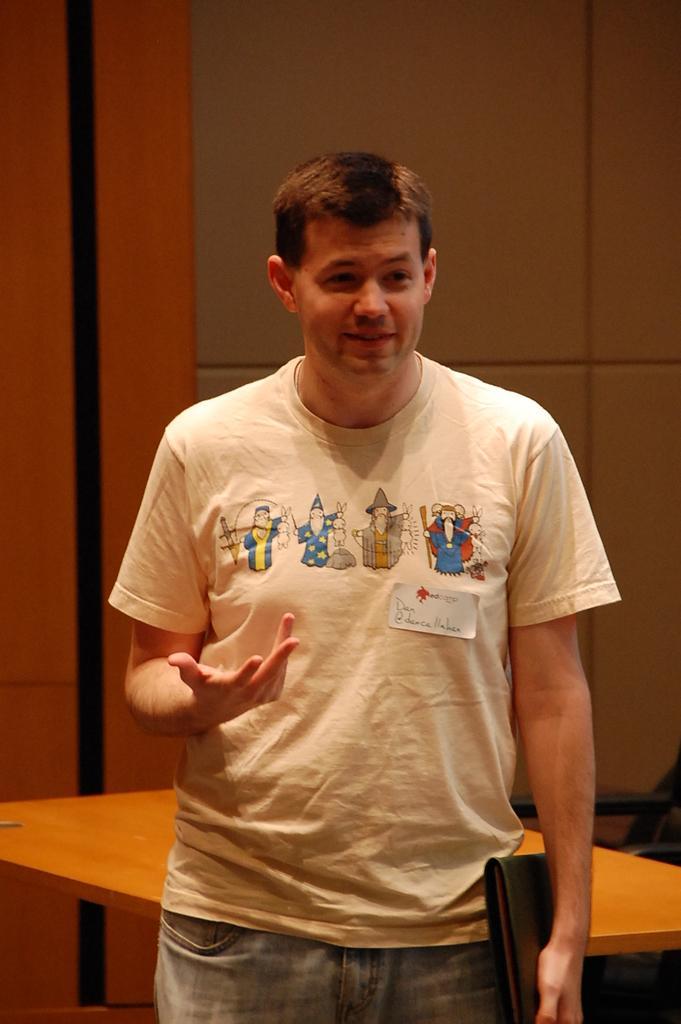Describe this image in one or two sentences. In this image in the center there is one man who is standing, and he is holding a file. And in the background there is a table and there is some object, and in the background there is wall. 